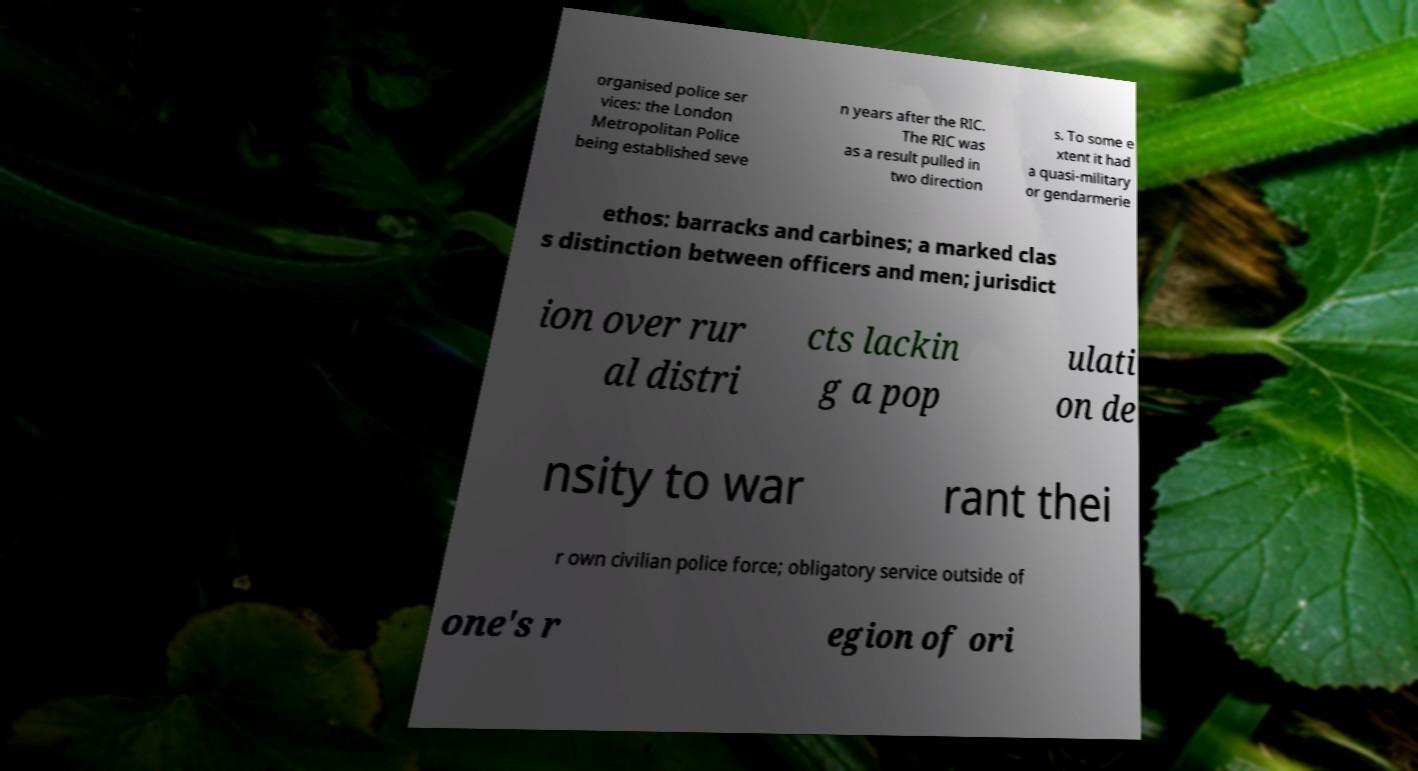Please identify and transcribe the text found in this image. organised police ser vices: the London Metropolitan Police being established seve n years after the RIC. The RIC was as a result pulled in two direction s. To some e xtent it had a quasi-military or gendarmerie ethos: barracks and carbines; a marked clas s distinction between officers and men; jurisdict ion over rur al distri cts lackin g a pop ulati on de nsity to war rant thei r own civilian police force; obligatory service outside of one's r egion of ori 